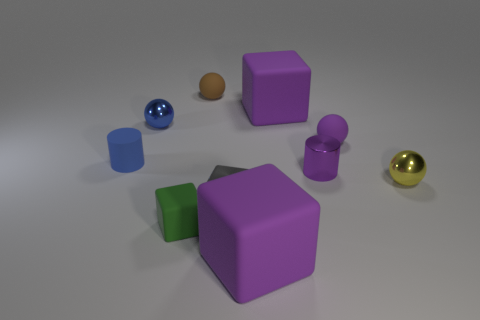There is a ball that is the same color as the tiny shiny cylinder; what is it made of?
Give a very brief answer. Rubber. There is a blue shiny object; is it the same shape as the matte object on the left side of the tiny green matte cube?
Provide a short and direct response. No. What shape is the gray metal object that is the same size as the brown matte thing?
Make the answer very short. Cube. Is the metallic cube the same color as the shiny cylinder?
Ensure brevity in your answer.  No. What size is the metal block on the right side of the green matte object?
Offer a terse response. Small. There is a rubber block that is on the left side of the brown rubber thing; does it have the same size as the small purple metal thing?
Provide a short and direct response. Yes. There is a large object to the right of the large matte cube that is in front of the matte block behind the tiny green matte cube; what color is it?
Your answer should be very brief. Purple. There is a tiny rubber object that is in front of the yellow thing; is its color the same as the metal cube?
Provide a short and direct response. No. How many objects are both behind the small purple ball and left of the small green cube?
Give a very brief answer. 1. The blue rubber thing that is the same shape as the purple shiny thing is what size?
Your answer should be very brief. Small. 